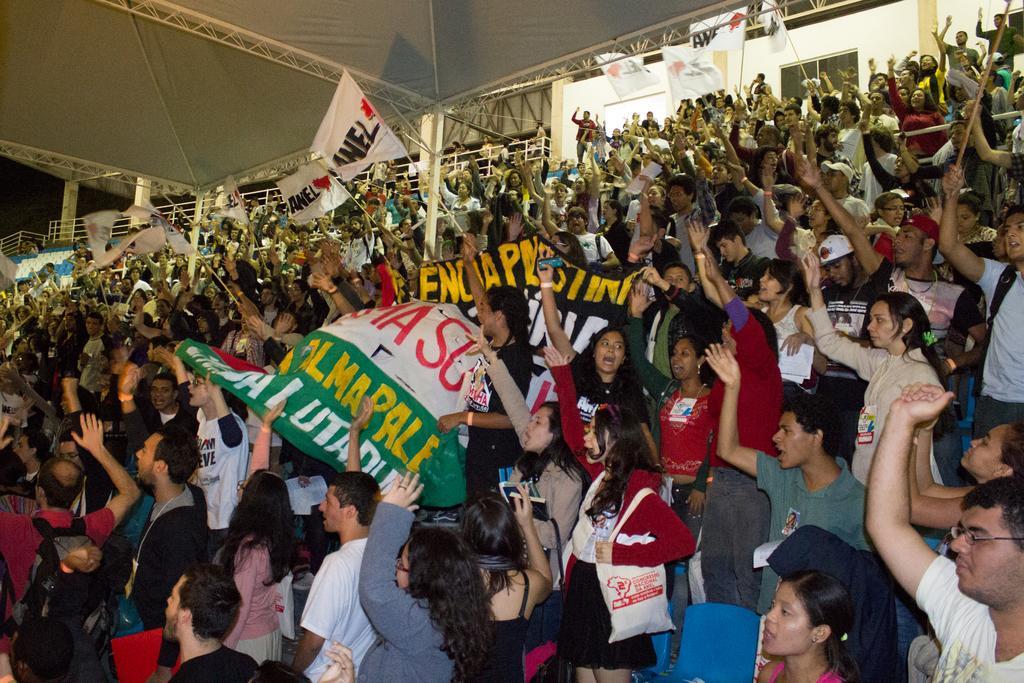How would you summarize this image in a sentence or two? In this image we can see many people are standing in the stadium by holding banners and flags. In the background, we can see the wall. 